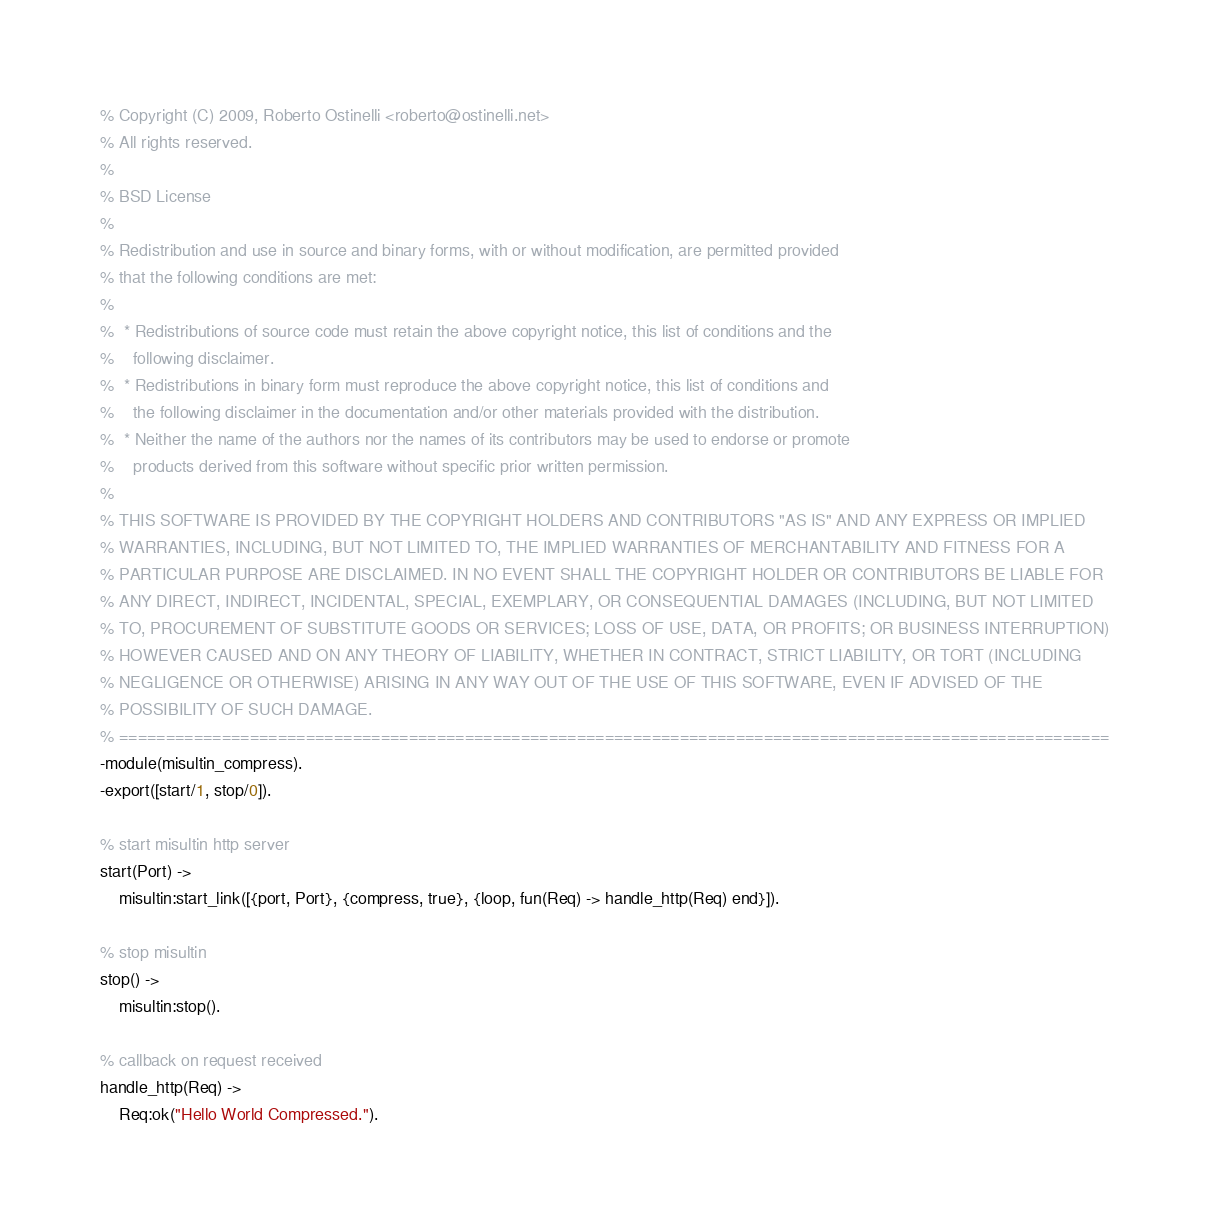<code> <loc_0><loc_0><loc_500><loc_500><_Erlang_>% Copyright (C) 2009, Roberto Ostinelli <roberto@ostinelli.net>
% All rights reserved.
%
% BSD License
% 
% Redistribution and use in source and binary forms, with or without modification, are permitted provided
% that the following conditions are met:
%
%  * Redistributions of source code must retain the above copyright notice, this list of conditions and the
%    following disclaimer.
%  * Redistributions in binary form must reproduce the above copyright notice, this list of conditions and
%    the following disclaimer in the documentation and/or other materials provided with the distribution.
%  * Neither the name of the authors nor the names of its contributors may be used to endorse or promote
%    products derived from this software without specific prior written permission.
%
% THIS SOFTWARE IS PROVIDED BY THE COPYRIGHT HOLDERS AND CONTRIBUTORS "AS IS" AND ANY EXPRESS OR IMPLIED
% WARRANTIES, INCLUDING, BUT NOT LIMITED TO, THE IMPLIED WARRANTIES OF MERCHANTABILITY AND FITNESS FOR A
% PARTICULAR PURPOSE ARE DISCLAIMED. IN NO EVENT SHALL THE COPYRIGHT HOLDER OR CONTRIBUTORS BE LIABLE FOR
% ANY DIRECT, INDIRECT, INCIDENTAL, SPECIAL, EXEMPLARY, OR CONSEQUENTIAL DAMAGES (INCLUDING, BUT NOT LIMITED
% TO, PROCUREMENT OF SUBSTITUTE GOODS OR SERVICES; LOSS OF USE, DATA, OR PROFITS; OR BUSINESS INTERRUPTION)
% HOWEVER CAUSED AND ON ANY THEORY OF LIABILITY, WHETHER IN CONTRACT, STRICT LIABILITY, OR TORT (INCLUDING
% NEGLIGENCE OR OTHERWISE) ARISING IN ANY WAY OUT OF THE USE OF THIS SOFTWARE, EVEN IF ADVISED OF THE
% POSSIBILITY OF SUCH DAMAGE.
% ==========================================================================================================
-module(misultin_compress).
-export([start/1, stop/0]).

% start misultin http server
start(Port) ->
	misultin:start_link([{port, Port}, {compress, true}, {loop, fun(Req) -> handle_http(Req) end}]).

% stop misultin
stop() ->
	misultin:stop().

% callback on request received
handle_http(Req) ->	
	Req:ok("Hello World Compressed.").
</code> 